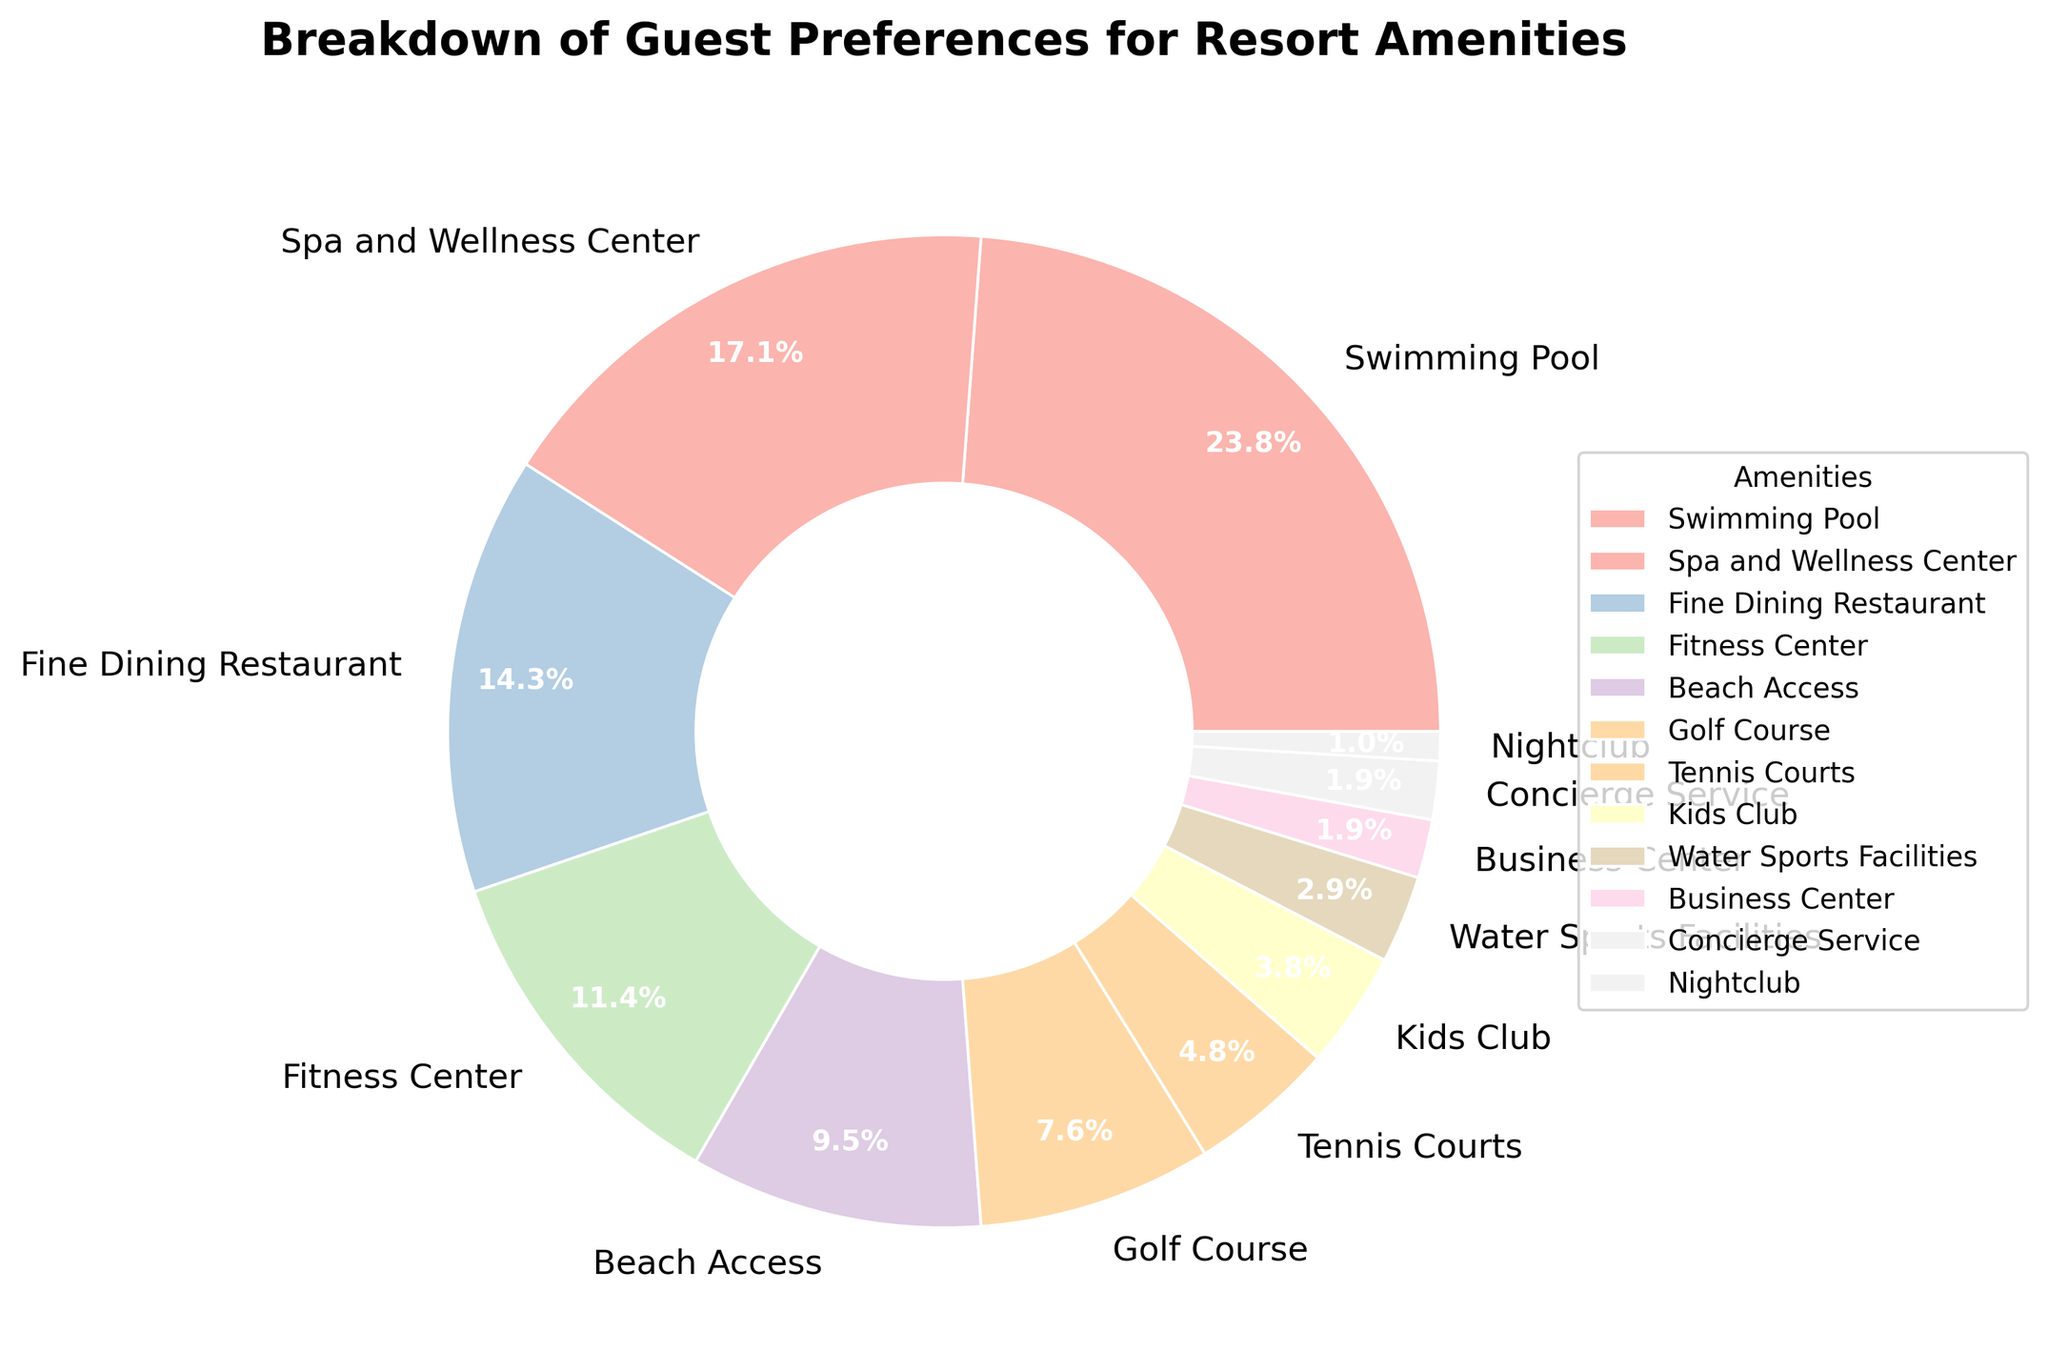What percentage of guests prefer Spa and Wellness Center? From the pie chart, identify the "Spa and Wellness Center" segment and read its associated percentage.
Answer: 18% Which amenity has the highest guest preference? Look for the segment with the largest percentage on the pie chart. The segment labeled "Swimming Pool" occupies the largest portion.
Answer: Swimming Pool How much more popular is the Swimming Pool than the Fitness Center? The Swimming Pool has 25% preference and the Fitness Center has 12% preference. Subtract 12% from 25% to get the difference.
Answer: 13% What is the combined percentage of guests who prefer Tennis Courts and Kids Club? The preference for Tennis Courts is 5% and for Kids Club is 4%. Add these two percentages together: 5% + 4% = 9%.
Answer: 9% Which amenity is preferred by exactly 10% of guests? Read through each segment's label and percentage on the pie chart to find the one with "10%" - it is "Beach Access."
Answer: Beach Access How does the preference for Fine Dining Restaurant compare to the preference for Fitness Center? The Fine Dining Restaurant is preferred by 15% of guests, whereas the Fitness Center is preferred by 12%. 15% is greater than 12%, indicating Fine Dining Restaurant is more popular.
Answer: Fine Dining Restaurant If we group Swimming Pool, Spa and Wellness Center, and Fine Dining Restaurant together, what percentage of guests prefer these amenities? Sum the percentages of Swimming Pool (25%), Spa and Wellness Center (18%), and Fine Dining Restaurant (15%). The total is 25% + 18% + 15% = 58%.
Answer: 58% How does the guest preference for Golf Course and Water Sports Facilities together compare to the preference for Fitness Center alone? Sum the percentages of Golf Course (8%) and Water Sports Facilities (3%) to get 11%. Compare this to Fitness Center (12%). 11% is less than 12%.
Answer: Less Which amenity has the lowest preference and what is its percentage? Identify the smallest segment in the pie chart, which is "Nightclub" with a percentage of 1%.
Answer: Nightclub, 1% How many amenities have a preference of 5% or less? Identify all segments in the pie chart with percentages 5% or less: Tennis Courts (5%), Kids Club (4%), Water Sports Facilities (3%), Business Center (2%), Concierge Service (2%), Nightclub (1%). Count these segments.
Answer: 6 